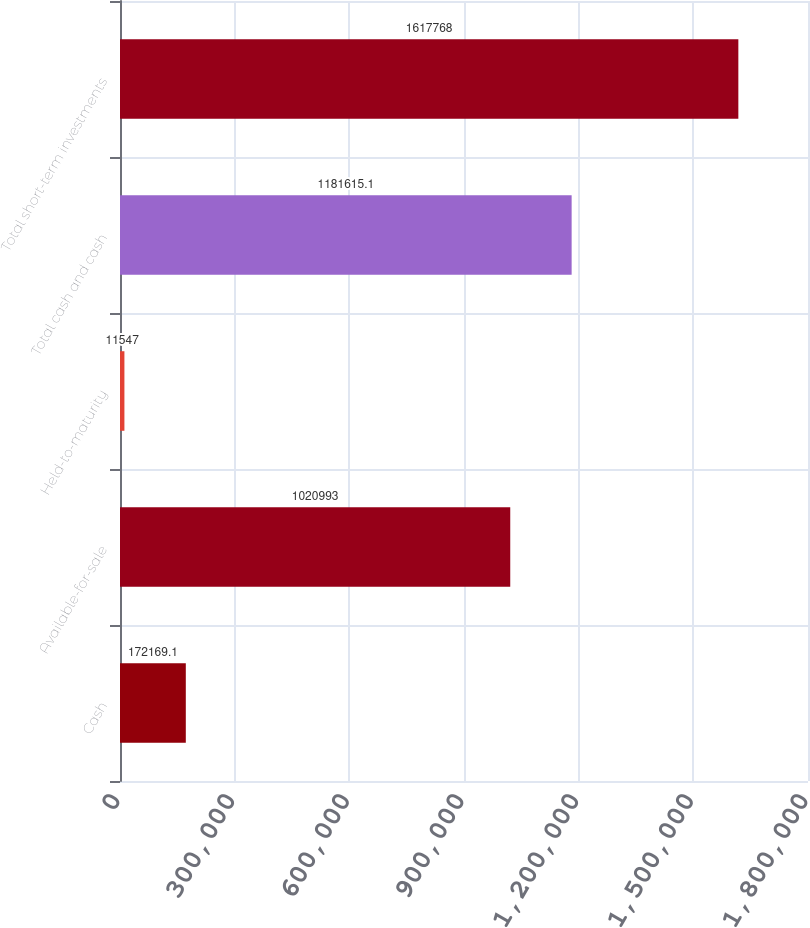Convert chart. <chart><loc_0><loc_0><loc_500><loc_500><bar_chart><fcel>Cash<fcel>Available-for-sale<fcel>Held-to-maturity<fcel>Total cash and cash<fcel>Total short-term investments<nl><fcel>172169<fcel>1.02099e+06<fcel>11547<fcel>1.18162e+06<fcel>1.61777e+06<nl></chart> 